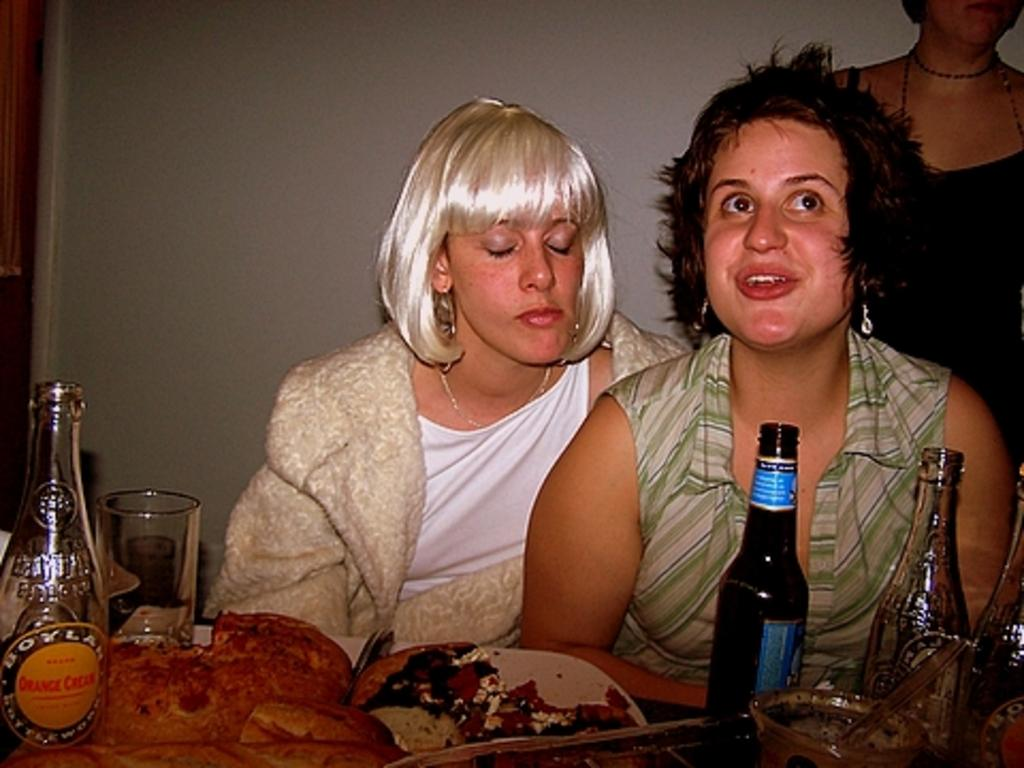How many women are in the image? There are two women in the image. What are the women doing in the image? The women are sitting on chairs. What can be seen on the table in the image? There are plates, bottles, glasses, and food on the table. What is visible in the background of the image? There is a wall in the background of the image. What type of button is the donkey wearing in the image? There is no donkey or button present in the image. What subject is being taught in the class depicted in the image? There is no class or subject being taught in the image; it features two women sitting on chairs with a table in front of them. 